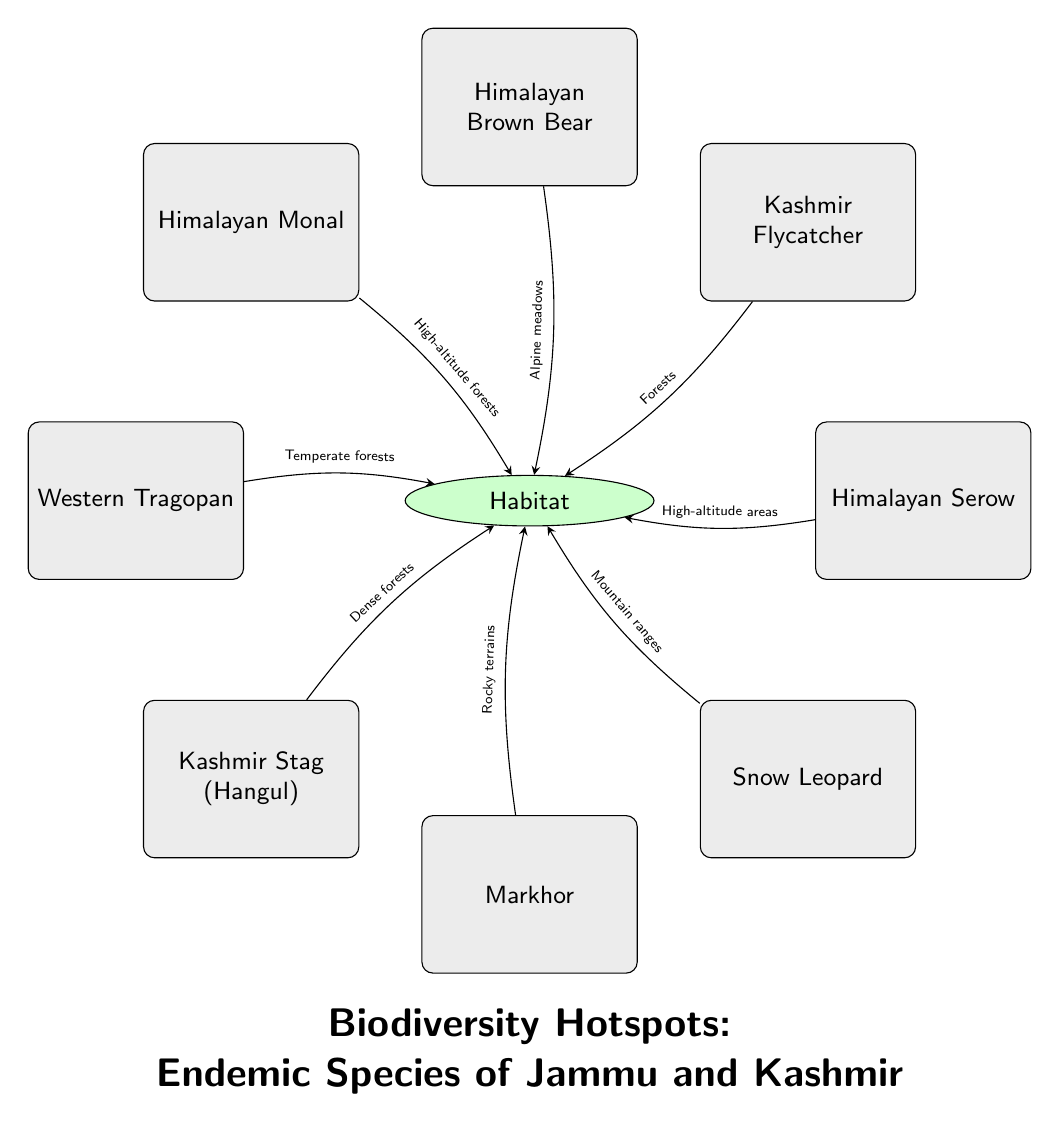What are the endemic species illustrated in the diagram? The diagram lists eight endemic species of Jammu and Kashmir: Kashmir Stag, Markhor, Snow Leopard, Himalayan Serow, Kashmir Flycatcher, Himalayan Brown Bear, Himalayan Monal, and Western Tragopan.
Answer: Kashmir Stag, Markhor, Snow Leopard, Himalayan Serow, Kashmir Flycatcher, Himalayan Brown Bear, Himalayan Monal, Western Tragopan How many species are connected to the habitat? There are eight species nodes connected to the central habitat node, as indicated by the lines drawn from each species to the habitat.
Answer: 8 Which species are associated with dense forests? The Kashmir Stag and the Kashmir Flycatcher are both linked to dense forests, as shown by the edges that connect these species to the habitat with that specific connection type.
Answer: Kashmir Stag, Kashmir Flycatcher What type of terrain is the Markhor associated with? The diagram specifies that the Markhor is associated with rocky terrains, indicated by the edge that connects the Markhor node to the habitat.
Answer: Rocky terrains Which species requires high-altitude forests for its habitat? The Himalayan Monal is indicated as requiring high-altitude forests, shown by the directed edge from the Himalayan Monal to the habitat labeled with that mention.
Answer: Himalayan Monal What is the common habitat type for both the Snow Leopard and the Himalayan Serow? Both the Snow Leopard and the Himalayan Serow are connected to the habitat through mountain ranges and high-altitude areas respectively; however, they share a broader mountainous habitat context, showcasing their adaptation to similar highland environments.
Answer: Mountain ranges and high-altitude areas How many types of habitats are represented in the diagram? There are six types of habitats mentioned for the different species, as evidenced by the various labeled edges connecting multiple species to the habitat.
Answer: 6 Which two species are found in alpine meadows? The Himalayan Brown Bear is linked to alpine meadows, but no other species is indicated for this habitat type; thus, it uniquely represents that habitat connection.
Answer: Himalayan Brown Bear What is the habitat type associated with the Western Tragopan? The Western Tragopan is connected to temperate forests, as shown by the description along the edge that connects it to the habitat node.
Answer: Temperate forests 